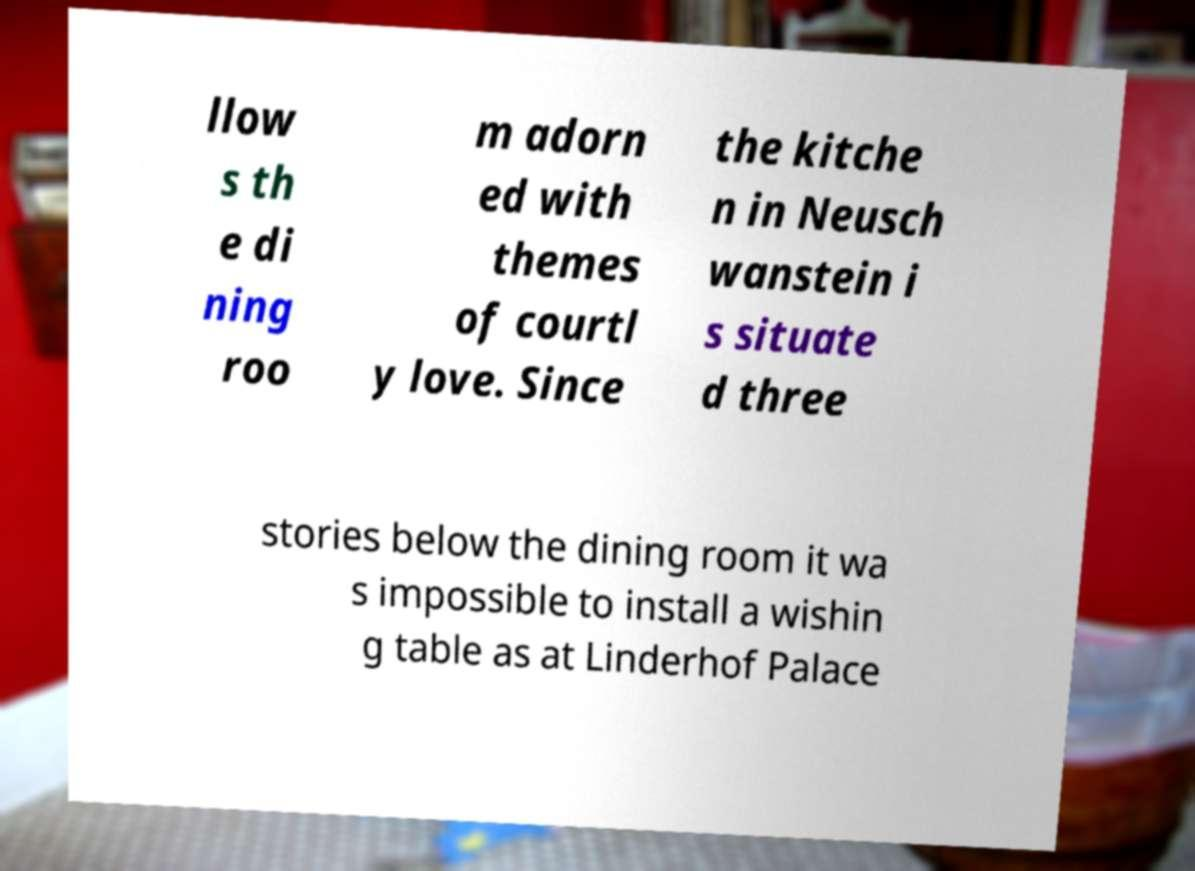Please identify and transcribe the text found in this image. llow s th e di ning roo m adorn ed with themes of courtl y love. Since the kitche n in Neusch wanstein i s situate d three stories below the dining room it wa s impossible to install a wishin g table as at Linderhof Palace 